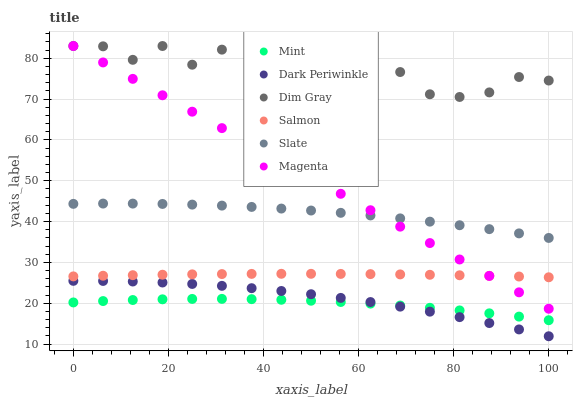Does Mint have the minimum area under the curve?
Answer yes or no. Yes. Does Dim Gray have the maximum area under the curve?
Answer yes or no. Yes. Does Slate have the minimum area under the curve?
Answer yes or no. No. Does Slate have the maximum area under the curve?
Answer yes or no. No. Is Magenta the smoothest?
Answer yes or no. Yes. Is Dim Gray the roughest?
Answer yes or no. Yes. Is Slate the smoothest?
Answer yes or no. No. Is Slate the roughest?
Answer yes or no. No. Does Dark Periwinkle have the lowest value?
Answer yes or no. Yes. Does Slate have the lowest value?
Answer yes or no. No. Does Magenta have the highest value?
Answer yes or no. Yes. Does Slate have the highest value?
Answer yes or no. No. Is Dark Periwinkle less than Dim Gray?
Answer yes or no. Yes. Is Slate greater than Salmon?
Answer yes or no. Yes. Does Dark Periwinkle intersect Mint?
Answer yes or no. Yes. Is Dark Periwinkle less than Mint?
Answer yes or no. No. Is Dark Periwinkle greater than Mint?
Answer yes or no. No. Does Dark Periwinkle intersect Dim Gray?
Answer yes or no. No. 